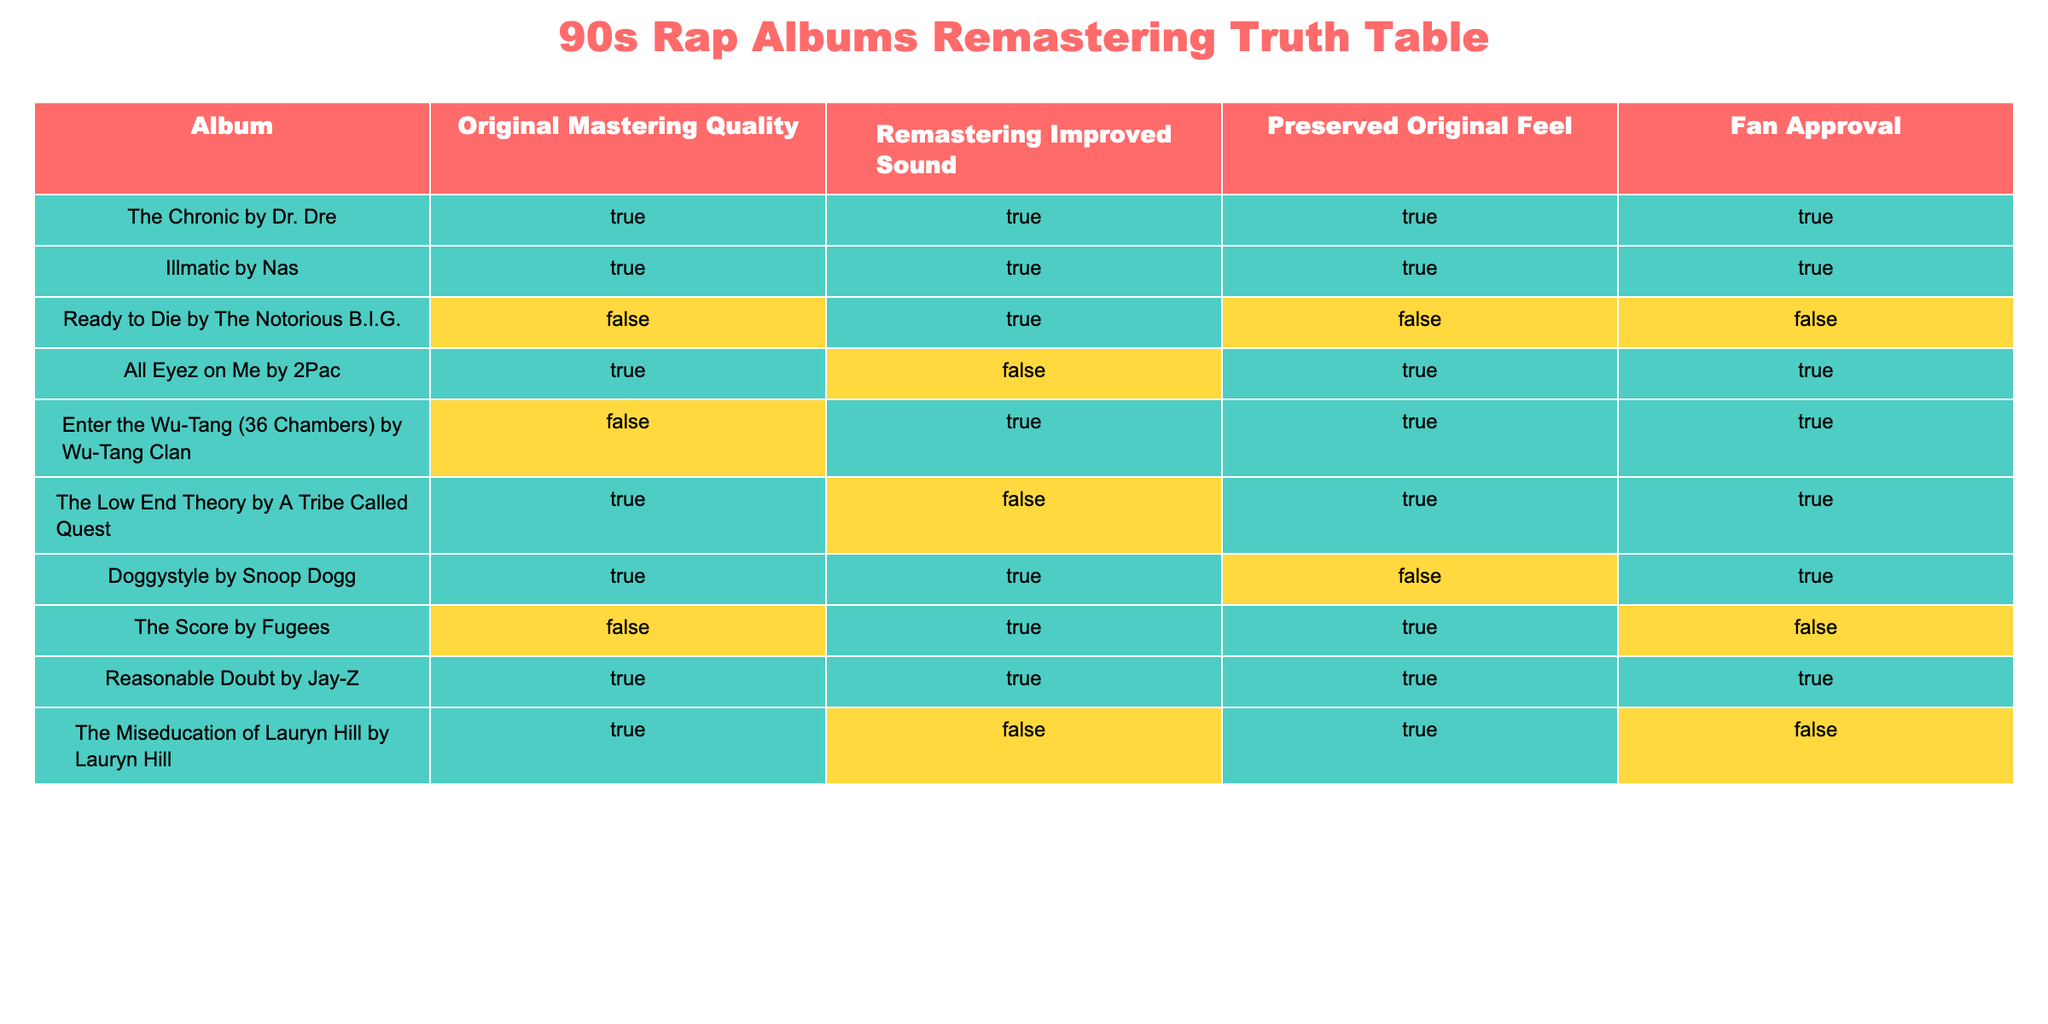What is the original mastering quality of "Illmatic" by Nas? According to the table, "Illmatic" by Nas has a column labeled "Original Mastering Quality," which indicates a value of True.
Answer: True How many albums have preserved their original feel after remastering? From the table, we can see that the albums that preserved their original feel are "The Chronic," "Illmatic," "All Eyez on Me," "Enter the Wu-Tang (36 Chambers)," "The Low End Theory," and "Doggystyle." This totals to six albums.
Answer: 6 Did "Ready to Die" by The Notorious B.I.G. receive improved sound during remastering? In the table, under the column "Remastering Improved Sound," "Ready to Die" shows a value of True, meaning the sound was improved.
Answer: True Which album has the highest fan approval despite not preserving the original feel? By examining the table, "Doggystyle" by Snoop Dogg has a fan approval value of True and did not preserve the original feel, as indicated by its value being False.
Answer: "Doggystyle" by Snoop Dogg What is the percentage of albums that have both improved sound and preserved the original feel? There are 10 albums total. The albums that have both improved sound (True) and preserved original feel (True) are "The Chronic," "Illmatic," and "Reasonable Doubt." Thus, 3 out of 10 albums gives (3/10)*100% = 30%.
Answer: 30% How many albums have True in both Remastering Improved Sound and Fan Approval columns? Reviewing the data, the albums that have True for both "Remastering Improved Sound" and "Fan Approval" are "The Chronic," "Illmatic," "Doggystyle," and "Reasonable Doubt," totaling four albums.
Answer: 4 Is it true that "The Miseducation of Lauryn Hill" received improved sound during remastering? In the table, the "Remastering Improved Sound" column lists a value of False for "The Miseducation of Lauryn Hill," which confirms that it did not receive improved sound.
Answer: False Which two albums both have True for original mastering quality but False for fan approval? The albums "The Score" by Fugees and "The Miseducation of Lauryn Hill" both show True for "Original Mastering Quality" but have False for "Fan Approval."
Answer: "The Score" and "The Miseducation of Lauryn Hill" 